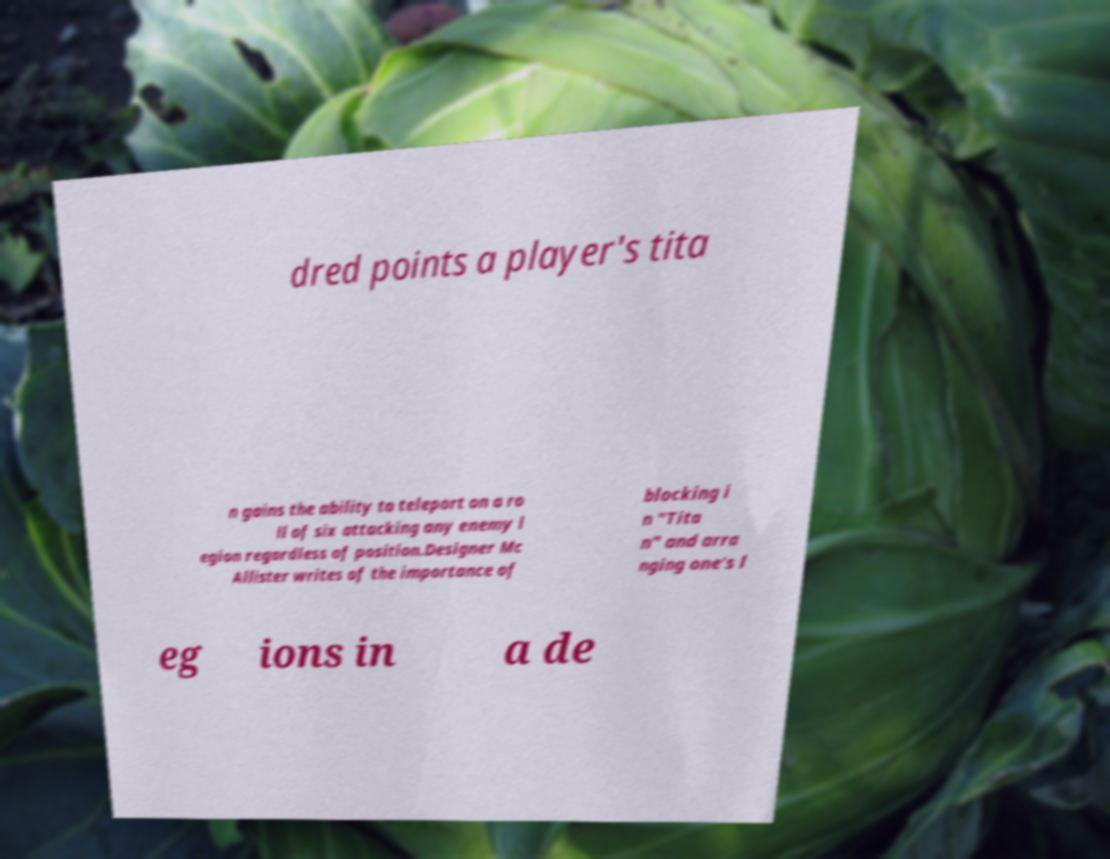Please identify and transcribe the text found in this image. dred points a player's tita n gains the ability to teleport on a ro ll of six attacking any enemy l egion regardless of position.Designer Mc Allister writes of the importance of blocking i n "Tita n" and arra nging one's l eg ions in a de 